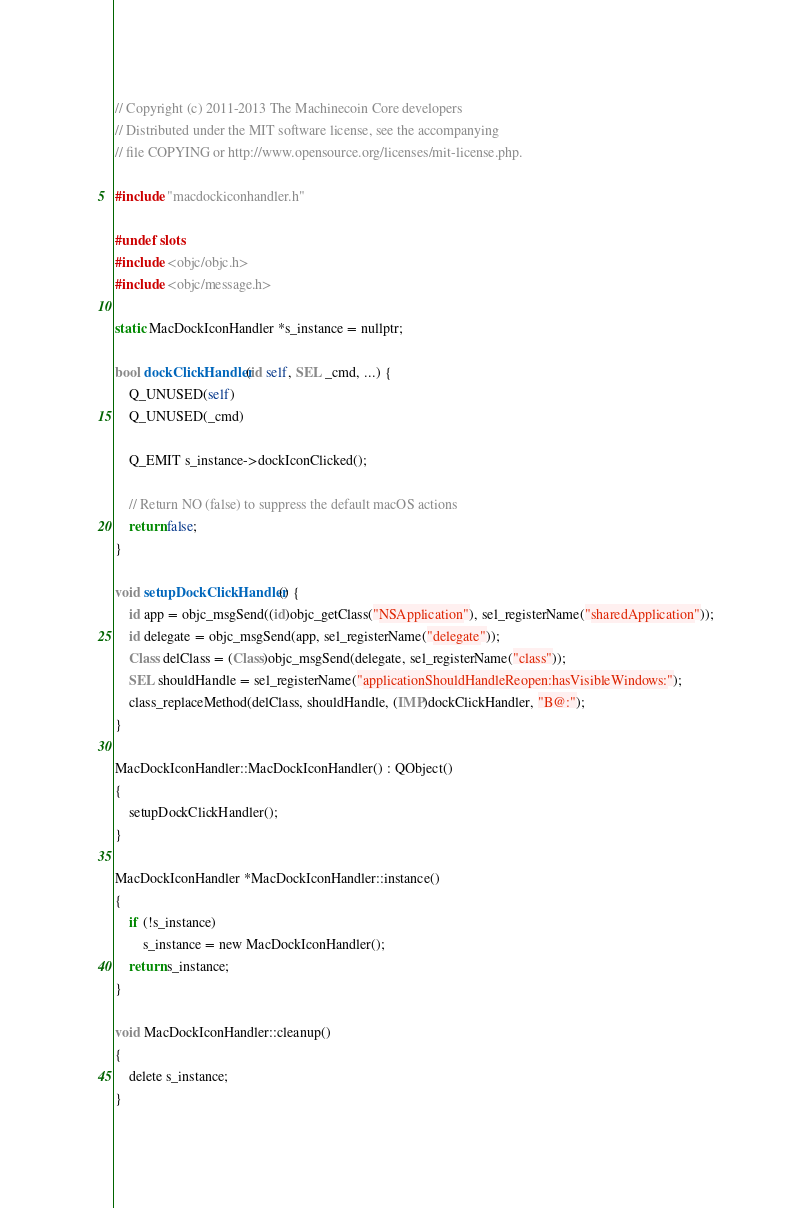Convert code to text. <code><loc_0><loc_0><loc_500><loc_500><_ObjectiveC_>// Copyright (c) 2011-2013 The Machinecoin Core developers
// Distributed under the MIT software license, see the accompanying
// file COPYING or http://www.opensource.org/licenses/mit-license.php.

#include "macdockiconhandler.h"

#undef slots
#include <objc/objc.h>
#include <objc/message.h>

static MacDockIconHandler *s_instance = nullptr;

bool dockClickHandler(id self, SEL _cmd, ...) {
    Q_UNUSED(self)
    Q_UNUSED(_cmd)

    Q_EMIT s_instance->dockIconClicked();

    // Return NO (false) to suppress the default macOS actions
    return false;
}

void setupDockClickHandler() {
    id app = objc_msgSend((id)objc_getClass("NSApplication"), sel_registerName("sharedApplication"));
    id delegate = objc_msgSend(app, sel_registerName("delegate"));
    Class delClass = (Class)objc_msgSend(delegate, sel_registerName("class"));
    SEL shouldHandle = sel_registerName("applicationShouldHandleReopen:hasVisibleWindows:");
    class_replaceMethod(delClass, shouldHandle, (IMP)dockClickHandler, "B@:");
}

MacDockIconHandler::MacDockIconHandler() : QObject()
{
    setupDockClickHandler();
}

MacDockIconHandler *MacDockIconHandler::instance()
{
    if (!s_instance)
        s_instance = new MacDockIconHandler();
    return s_instance;
}

void MacDockIconHandler::cleanup()
{
    delete s_instance;
}
</code> 